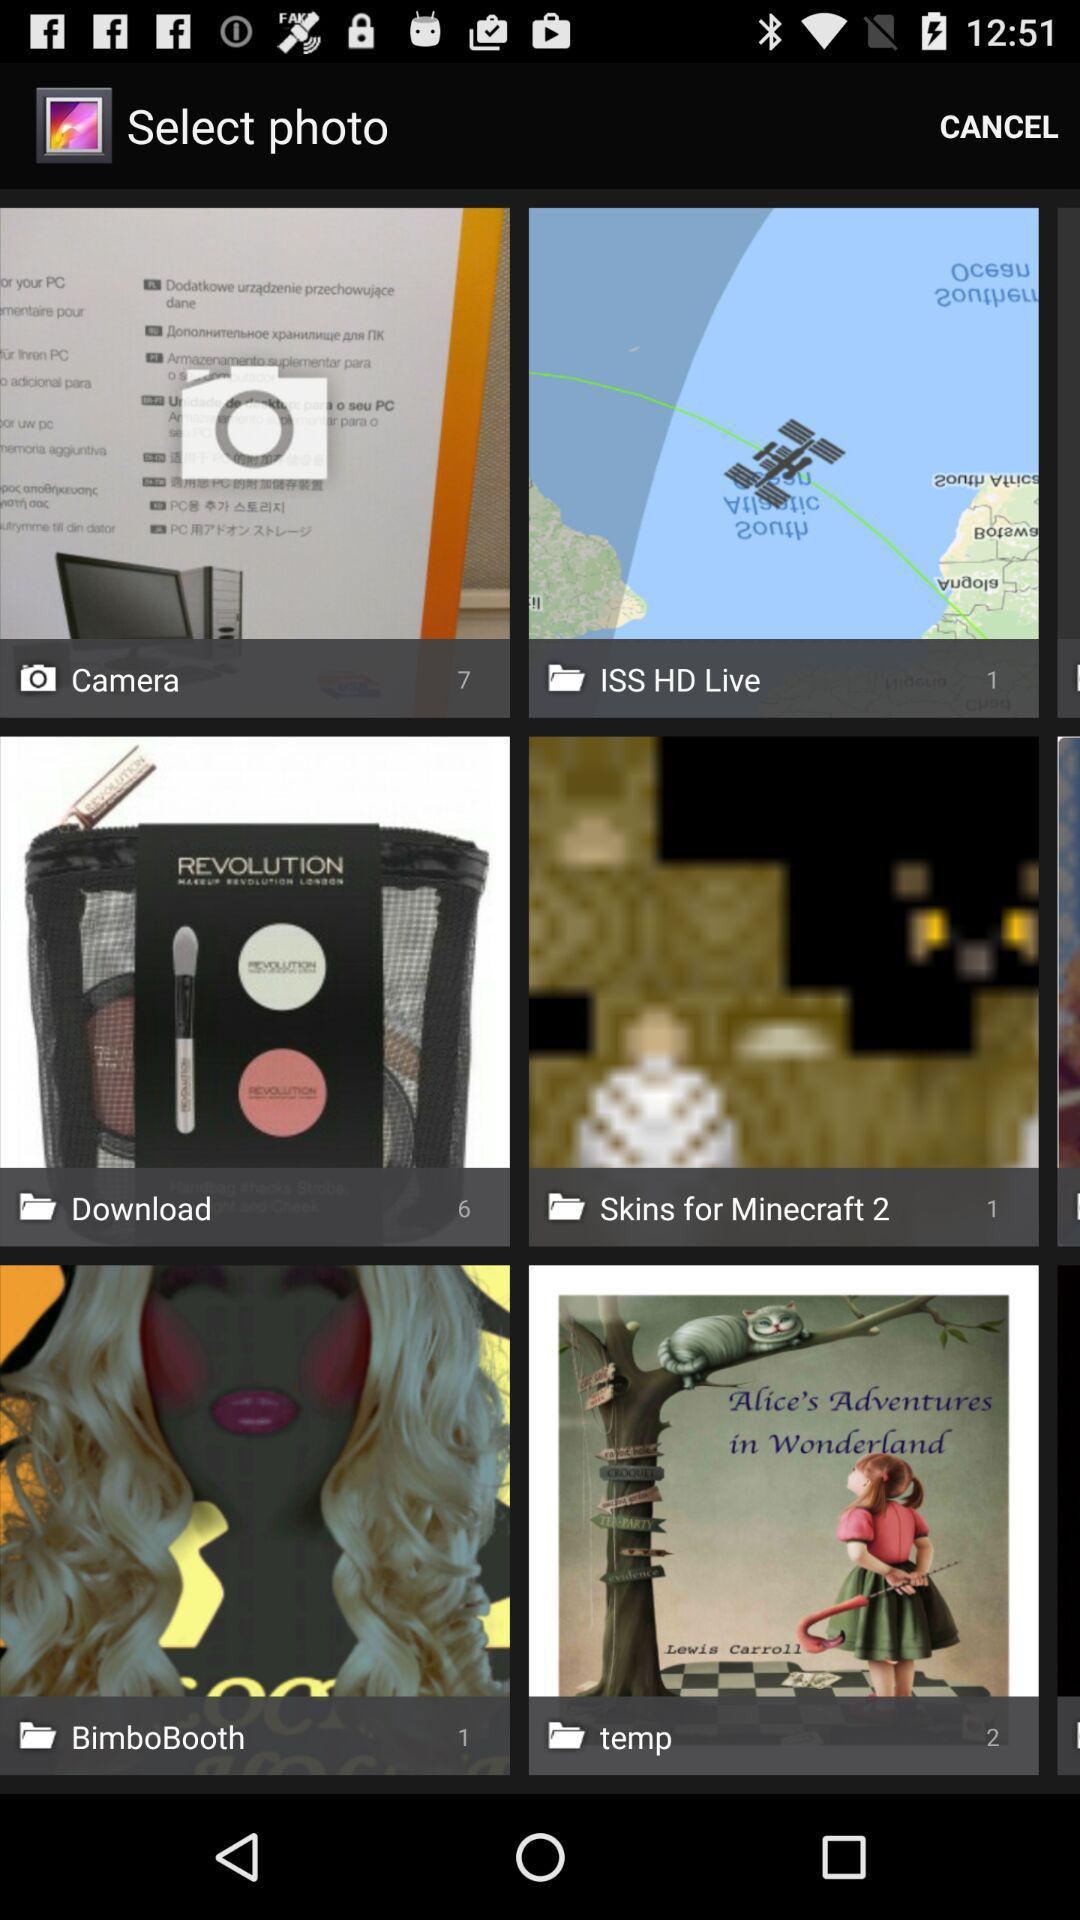What is the number of images in "temp" album? The number of images in "temp" album is 2. 